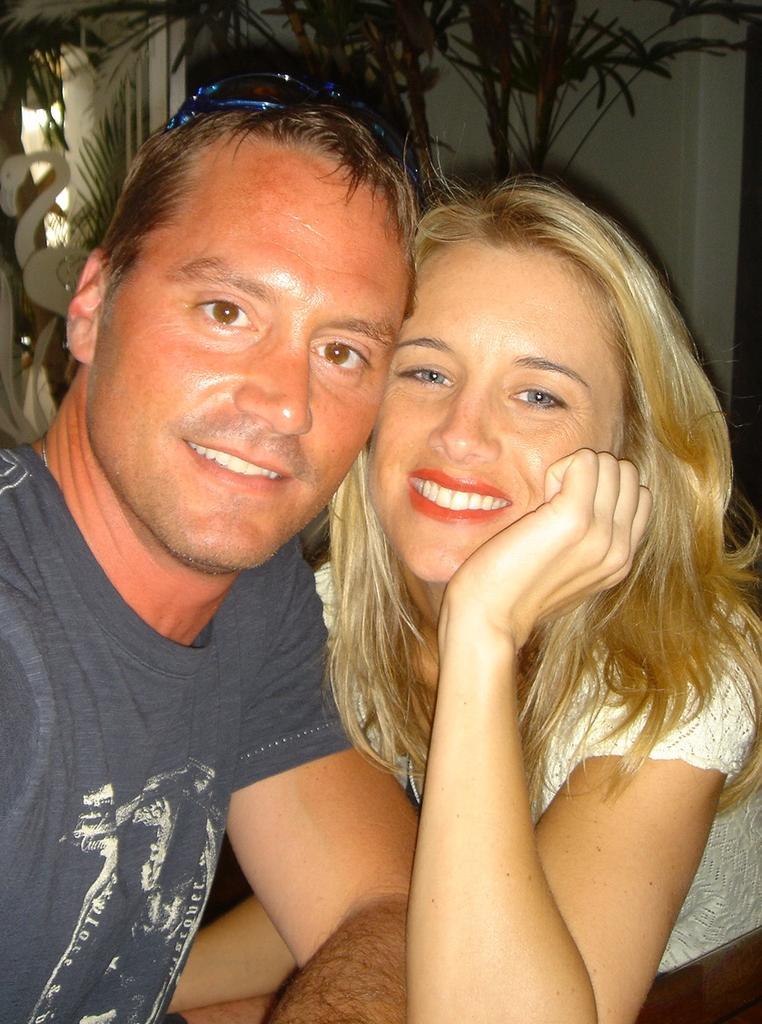Can you describe this image briefly? In this picture we can see a man and a women. Both are smiling and this man is in t shirt and he has goggles on his head. This woman has brown color hair and she is in white color dress. And on the background there is a wall. 